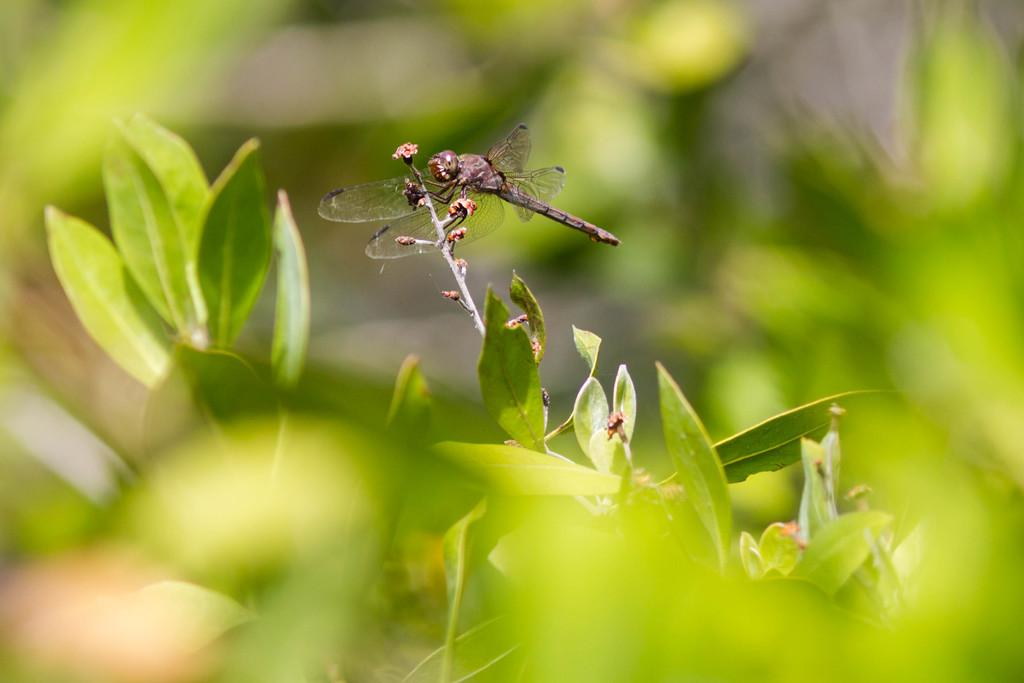What is the main subject of the image? The main subject of the image is a dragonfly. Where is the dragonfly located in the image? The dragonfly is on a plant. Can you describe the background of the image? The background of the image is blurred. What type of kettle can be seen in the image? There is no kettle present in the image. Is there a playground visible in the image? There is no playground present in the image. Can you see a rifle in the image? There is no rifle present in the image. 